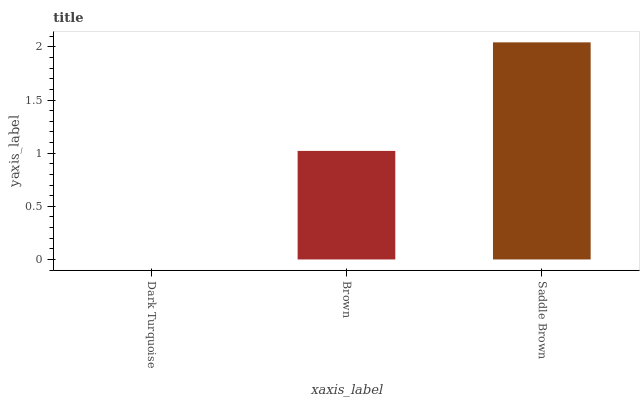Is Dark Turquoise the minimum?
Answer yes or no. Yes. Is Saddle Brown the maximum?
Answer yes or no. Yes. Is Brown the minimum?
Answer yes or no. No. Is Brown the maximum?
Answer yes or no. No. Is Brown greater than Dark Turquoise?
Answer yes or no. Yes. Is Dark Turquoise less than Brown?
Answer yes or no. Yes. Is Dark Turquoise greater than Brown?
Answer yes or no. No. Is Brown less than Dark Turquoise?
Answer yes or no. No. Is Brown the high median?
Answer yes or no. Yes. Is Brown the low median?
Answer yes or no. Yes. Is Dark Turquoise the high median?
Answer yes or no. No. Is Dark Turquoise the low median?
Answer yes or no. No. 